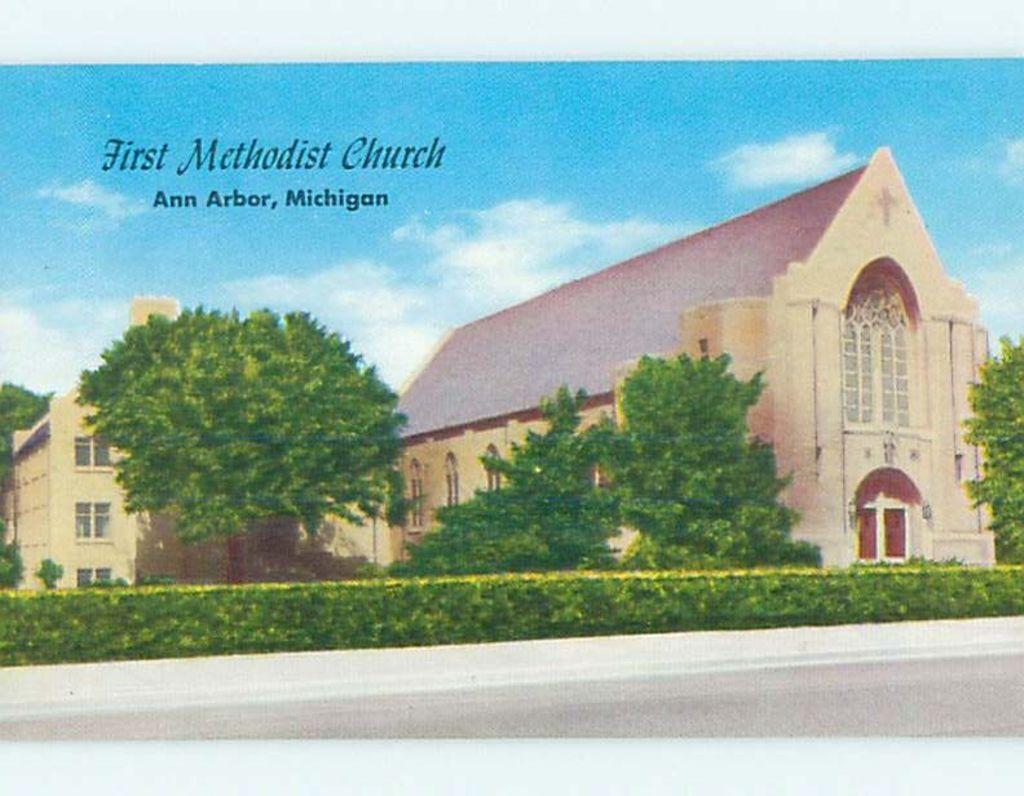Please provide a concise description of this image. In this image we can see a poster with some houses, trees, plants and a text on it. In the background, we can see the sky. 